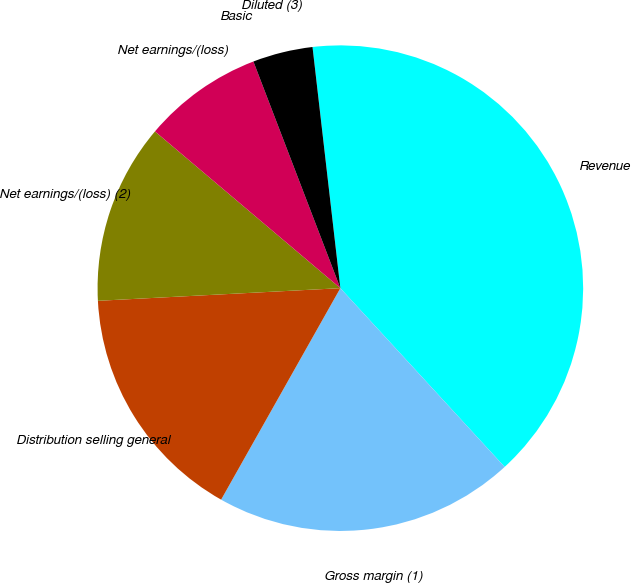Convert chart to OTSL. <chart><loc_0><loc_0><loc_500><loc_500><pie_chart><fcel>Revenue<fcel>Gross margin (1)<fcel>Distribution selling general<fcel>Net earnings/(loss) (2)<fcel>Net earnings/(loss)<fcel>Basic<fcel>Diluted (3)<nl><fcel>40.0%<fcel>20.0%<fcel>16.0%<fcel>12.0%<fcel>8.0%<fcel>0.0%<fcel>4.0%<nl></chart> 